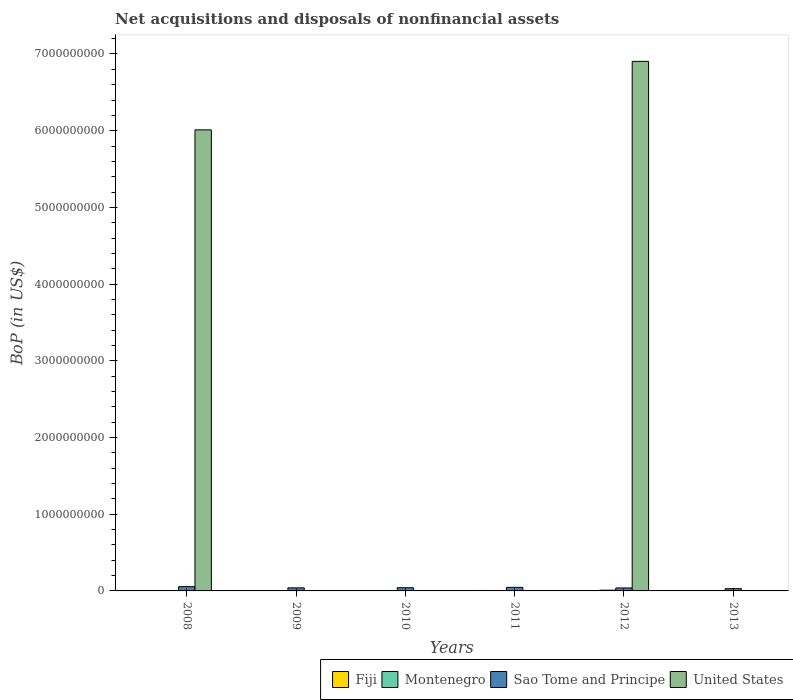How many bars are there on the 1st tick from the left?
Your answer should be compact. 3. In how many cases, is the number of bars for a given year not equal to the number of legend labels?
Give a very brief answer. 5. What is the Balance of Payments in Fiji in 2008?
Keep it short and to the point. 5.19e+06. Across all years, what is the maximum Balance of Payments in Montenegro?
Provide a short and direct response. 9.66e+06. Across all years, what is the minimum Balance of Payments in Sao Tome and Principe?
Give a very brief answer. 2.94e+07. In which year was the Balance of Payments in Fiji maximum?
Your response must be concise. 2011. What is the total Balance of Payments in United States in the graph?
Your response must be concise. 1.29e+1. What is the difference between the Balance of Payments in Fiji in 2009 and that in 2011?
Give a very brief answer. -3.56e+06. What is the difference between the Balance of Payments in Fiji in 2009 and the Balance of Payments in United States in 2013?
Provide a short and direct response. 2.36e+06. What is the average Balance of Payments in Sao Tome and Principe per year?
Provide a short and direct response. 4.20e+07. In the year 2009, what is the difference between the Balance of Payments in Montenegro and Balance of Payments in Fiji?
Offer a very short reply. 3.06e+05. In how many years, is the Balance of Payments in Fiji greater than 6600000000 US$?
Keep it short and to the point. 0. What is the ratio of the Balance of Payments in Fiji in 2009 to that in 2011?
Provide a succinct answer. 0.4. What is the difference between the highest and the second highest Balance of Payments in Fiji?
Provide a succinct answer. 7.21e+05. What is the difference between the highest and the lowest Balance of Payments in Sao Tome and Principe?
Offer a very short reply. 2.64e+07. In how many years, is the Balance of Payments in United States greater than the average Balance of Payments in United States taken over all years?
Your answer should be compact. 2. Is it the case that in every year, the sum of the Balance of Payments in Montenegro and Balance of Payments in Fiji is greater than the sum of Balance of Payments in United States and Balance of Payments in Sao Tome and Principe?
Give a very brief answer. No. Is it the case that in every year, the sum of the Balance of Payments in United States and Balance of Payments in Montenegro is greater than the Balance of Payments in Fiji?
Give a very brief answer. No. How many bars are there?
Your response must be concise. 17. Are all the bars in the graph horizontal?
Offer a terse response. No. How many years are there in the graph?
Your answer should be very brief. 6. Does the graph contain grids?
Provide a short and direct response. No. How many legend labels are there?
Ensure brevity in your answer.  4. What is the title of the graph?
Make the answer very short. Net acquisitions and disposals of nonfinancial assets. Does "Nicaragua" appear as one of the legend labels in the graph?
Offer a very short reply. No. What is the label or title of the Y-axis?
Your response must be concise. BoP (in US$). What is the BoP (in US$) in Fiji in 2008?
Keep it short and to the point. 5.19e+06. What is the BoP (in US$) in Montenegro in 2008?
Make the answer very short. 0. What is the BoP (in US$) in Sao Tome and Principe in 2008?
Offer a very short reply. 5.58e+07. What is the BoP (in US$) in United States in 2008?
Offer a terse response. 6.01e+09. What is the BoP (in US$) in Fiji in 2009?
Your answer should be compact. 2.36e+06. What is the BoP (in US$) in Montenegro in 2009?
Provide a succinct answer. 2.66e+06. What is the BoP (in US$) in Sao Tome and Principe in 2009?
Provide a succinct answer. 3.99e+07. What is the BoP (in US$) in United States in 2009?
Provide a succinct answer. 0. What is the BoP (in US$) in Fiji in 2010?
Provide a succinct answer. 2.92e+06. What is the BoP (in US$) of Sao Tome and Principe in 2010?
Offer a very short reply. 4.16e+07. What is the BoP (in US$) of Fiji in 2011?
Make the answer very short. 5.91e+06. What is the BoP (in US$) in Montenegro in 2011?
Ensure brevity in your answer.  0. What is the BoP (in US$) of Sao Tome and Principe in 2011?
Offer a very short reply. 4.65e+07. What is the BoP (in US$) of Fiji in 2012?
Provide a short and direct response. 3.96e+06. What is the BoP (in US$) in Montenegro in 2012?
Your answer should be very brief. 9.66e+06. What is the BoP (in US$) of Sao Tome and Principe in 2012?
Your response must be concise. 3.87e+07. What is the BoP (in US$) of United States in 2012?
Offer a terse response. 6.90e+09. What is the BoP (in US$) of Fiji in 2013?
Make the answer very short. 4.82e+06. What is the BoP (in US$) in Montenegro in 2013?
Provide a short and direct response. 3.47e+06. What is the BoP (in US$) of Sao Tome and Principe in 2013?
Provide a succinct answer. 2.94e+07. Across all years, what is the maximum BoP (in US$) in Fiji?
Give a very brief answer. 5.91e+06. Across all years, what is the maximum BoP (in US$) in Montenegro?
Keep it short and to the point. 9.66e+06. Across all years, what is the maximum BoP (in US$) of Sao Tome and Principe?
Keep it short and to the point. 5.58e+07. Across all years, what is the maximum BoP (in US$) in United States?
Give a very brief answer. 6.90e+09. Across all years, what is the minimum BoP (in US$) of Fiji?
Offer a terse response. 2.36e+06. Across all years, what is the minimum BoP (in US$) in Montenegro?
Offer a very short reply. 0. Across all years, what is the minimum BoP (in US$) of Sao Tome and Principe?
Ensure brevity in your answer.  2.94e+07. What is the total BoP (in US$) of Fiji in the graph?
Your answer should be very brief. 2.52e+07. What is the total BoP (in US$) of Montenegro in the graph?
Give a very brief answer. 1.58e+07. What is the total BoP (in US$) in Sao Tome and Principe in the graph?
Offer a terse response. 2.52e+08. What is the total BoP (in US$) in United States in the graph?
Keep it short and to the point. 1.29e+1. What is the difference between the BoP (in US$) of Fiji in 2008 and that in 2009?
Give a very brief answer. 2.84e+06. What is the difference between the BoP (in US$) of Sao Tome and Principe in 2008 and that in 2009?
Your response must be concise. 1.59e+07. What is the difference between the BoP (in US$) of Fiji in 2008 and that in 2010?
Offer a terse response. 2.27e+06. What is the difference between the BoP (in US$) of Sao Tome and Principe in 2008 and that in 2010?
Offer a very short reply. 1.41e+07. What is the difference between the BoP (in US$) in Fiji in 2008 and that in 2011?
Provide a short and direct response. -7.21e+05. What is the difference between the BoP (in US$) of Sao Tome and Principe in 2008 and that in 2011?
Give a very brief answer. 9.29e+06. What is the difference between the BoP (in US$) of Fiji in 2008 and that in 2012?
Offer a terse response. 1.23e+06. What is the difference between the BoP (in US$) of Sao Tome and Principe in 2008 and that in 2012?
Give a very brief answer. 1.71e+07. What is the difference between the BoP (in US$) of United States in 2008 and that in 2012?
Provide a succinct answer. -8.93e+08. What is the difference between the BoP (in US$) of Fiji in 2008 and that in 2013?
Ensure brevity in your answer.  3.70e+05. What is the difference between the BoP (in US$) in Sao Tome and Principe in 2008 and that in 2013?
Offer a terse response. 2.64e+07. What is the difference between the BoP (in US$) in Fiji in 2009 and that in 2010?
Offer a very short reply. -5.65e+05. What is the difference between the BoP (in US$) in Sao Tome and Principe in 2009 and that in 2010?
Make the answer very short. -1.75e+06. What is the difference between the BoP (in US$) in Fiji in 2009 and that in 2011?
Offer a very short reply. -3.56e+06. What is the difference between the BoP (in US$) in Sao Tome and Principe in 2009 and that in 2011?
Your answer should be compact. -6.60e+06. What is the difference between the BoP (in US$) in Fiji in 2009 and that in 2012?
Offer a terse response. -1.60e+06. What is the difference between the BoP (in US$) in Montenegro in 2009 and that in 2012?
Your answer should be compact. -6.99e+06. What is the difference between the BoP (in US$) of Sao Tome and Principe in 2009 and that in 2012?
Make the answer very short. 1.17e+06. What is the difference between the BoP (in US$) in Fiji in 2009 and that in 2013?
Provide a short and direct response. -2.47e+06. What is the difference between the BoP (in US$) in Montenegro in 2009 and that in 2013?
Make the answer very short. -8.10e+05. What is the difference between the BoP (in US$) of Sao Tome and Principe in 2009 and that in 2013?
Provide a succinct answer. 1.05e+07. What is the difference between the BoP (in US$) of Fiji in 2010 and that in 2011?
Your answer should be very brief. -2.99e+06. What is the difference between the BoP (in US$) of Sao Tome and Principe in 2010 and that in 2011?
Offer a terse response. -4.85e+06. What is the difference between the BoP (in US$) of Fiji in 2010 and that in 2012?
Offer a very short reply. -1.04e+06. What is the difference between the BoP (in US$) of Sao Tome and Principe in 2010 and that in 2012?
Ensure brevity in your answer.  2.92e+06. What is the difference between the BoP (in US$) in Fiji in 2010 and that in 2013?
Give a very brief answer. -1.90e+06. What is the difference between the BoP (in US$) in Sao Tome and Principe in 2010 and that in 2013?
Provide a short and direct response. 1.22e+07. What is the difference between the BoP (in US$) of Fiji in 2011 and that in 2012?
Your answer should be very brief. 1.95e+06. What is the difference between the BoP (in US$) of Sao Tome and Principe in 2011 and that in 2012?
Make the answer very short. 7.77e+06. What is the difference between the BoP (in US$) of Fiji in 2011 and that in 2013?
Ensure brevity in your answer.  1.09e+06. What is the difference between the BoP (in US$) in Sao Tome and Principe in 2011 and that in 2013?
Provide a succinct answer. 1.71e+07. What is the difference between the BoP (in US$) in Fiji in 2012 and that in 2013?
Offer a terse response. -8.61e+05. What is the difference between the BoP (in US$) in Montenegro in 2012 and that in 2013?
Your answer should be compact. 6.18e+06. What is the difference between the BoP (in US$) in Sao Tome and Principe in 2012 and that in 2013?
Give a very brief answer. 9.30e+06. What is the difference between the BoP (in US$) in Fiji in 2008 and the BoP (in US$) in Montenegro in 2009?
Offer a very short reply. 2.53e+06. What is the difference between the BoP (in US$) of Fiji in 2008 and the BoP (in US$) of Sao Tome and Principe in 2009?
Make the answer very short. -3.47e+07. What is the difference between the BoP (in US$) in Fiji in 2008 and the BoP (in US$) in Sao Tome and Principe in 2010?
Ensure brevity in your answer.  -3.64e+07. What is the difference between the BoP (in US$) of Fiji in 2008 and the BoP (in US$) of Sao Tome and Principe in 2011?
Make the answer very short. -4.13e+07. What is the difference between the BoP (in US$) in Fiji in 2008 and the BoP (in US$) in Montenegro in 2012?
Your answer should be compact. -4.46e+06. What is the difference between the BoP (in US$) of Fiji in 2008 and the BoP (in US$) of Sao Tome and Principe in 2012?
Your response must be concise. -3.35e+07. What is the difference between the BoP (in US$) of Fiji in 2008 and the BoP (in US$) of United States in 2012?
Keep it short and to the point. -6.90e+09. What is the difference between the BoP (in US$) in Sao Tome and Principe in 2008 and the BoP (in US$) in United States in 2012?
Your answer should be very brief. -6.85e+09. What is the difference between the BoP (in US$) in Fiji in 2008 and the BoP (in US$) in Montenegro in 2013?
Provide a short and direct response. 1.72e+06. What is the difference between the BoP (in US$) in Fiji in 2008 and the BoP (in US$) in Sao Tome and Principe in 2013?
Make the answer very short. -2.42e+07. What is the difference between the BoP (in US$) of Fiji in 2009 and the BoP (in US$) of Sao Tome and Principe in 2010?
Ensure brevity in your answer.  -3.93e+07. What is the difference between the BoP (in US$) in Montenegro in 2009 and the BoP (in US$) in Sao Tome and Principe in 2010?
Make the answer very short. -3.90e+07. What is the difference between the BoP (in US$) in Fiji in 2009 and the BoP (in US$) in Sao Tome and Principe in 2011?
Offer a very short reply. -4.41e+07. What is the difference between the BoP (in US$) of Montenegro in 2009 and the BoP (in US$) of Sao Tome and Principe in 2011?
Ensure brevity in your answer.  -4.38e+07. What is the difference between the BoP (in US$) of Fiji in 2009 and the BoP (in US$) of Montenegro in 2012?
Ensure brevity in your answer.  -7.30e+06. What is the difference between the BoP (in US$) in Fiji in 2009 and the BoP (in US$) in Sao Tome and Principe in 2012?
Provide a succinct answer. -3.64e+07. What is the difference between the BoP (in US$) of Fiji in 2009 and the BoP (in US$) of United States in 2012?
Give a very brief answer. -6.90e+09. What is the difference between the BoP (in US$) of Montenegro in 2009 and the BoP (in US$) of Sao Tome and Principe in 2012?
Make the answer very short. -3.61e+07. What is the difference between the BoP (in US$) in Montenegro in 2009 and the BoP (in US$) in United States in 2012?
Ensure brevity in your answer.  -6.90e+09. What is the difference between the BoP (in US$) in Sao Tome and Principe in 2009 and the BoP (in US$) in United States in 2012?
Offer a very short reply. -6.86e+09. What is the difference between the BoP (in US$) in Fiji in 2009 and the BoP (in US$) in Montenegro in 2013?
Provide a short and direct response. -1.12e+06. What is the difference between the BoP (in US$) of Fiji in 2009 and the BoP (in US$) of Sao Tome and Principe in 2013?
Ensure brevity in your answer.  -2.71e+07. What is the difference between the BoP (in US$) of Montenegro in 2009 and the BoP (in US$) of Sao Tome and Principe in 2013?
Your answer should be compact. -2.68e+07. What is the difference between the BoP (in US$) of Fiji in 2010 and the BoP (in US$) of Sao Tome and Principe in 2011?
Your answer should be compact. -4.36e+07. What is the difference between the BoP (in US$) of Fiji in 2010 and the BoP (in US$) of Montenegro in 2012?
Offer a terse response. -6.73e+06. What is the difference between the BoP (in US$) of Fiji in 2010 and the BoP (in US$) of Sao Tome and Principe in 2012?
Offer a very short reply. -3.58e+07. What is the difference between the BoP (in US$) in Fiji in 2010 and the BoP (in US$) in United States in 2012?
Provide a short and direct response. -6.90e+09. What is the difference between the BoP (in US$) in Sao Tome and Principe in 2010 and the BoP (in US$) in United States in 2012?
Your response must be concise. -6.86e+09. What is the difference between the BoP (in US$) of Fiji in 2010 and the BoP (in US$) of Montenegro in 2013?
Provide a succinct answer. -5.51e+05. What is the difference between the BoP (in US$) of Fiji in 2010 and the BoP (in US$) of Sao Tome and Principe in 2013?
Offer a very short reply. -2.65e+07. What is the difference between the BoP (in US$) in Fiji in 2011 and the BoP (in US$) in Montenegro in 2012?
Offer a very short reply. -3.74e+06. What is the difference between the BoP (in US$) in Fiji in 2011 and the BoP (in US$) in Sao Tome and Principe in 2012?
Give a very brief answer. -3.28e+07. What is the difference between the BoP (in US$) in Fiji in 2011 and the BoP (in US$) in United States in 2012?
Offer a terse response. -6.90e+09. What is the difference between the BoP (in US$) in Sao Tome and Principe in 2011 and the BoP (in US$) in United States in 2012?
Provide a short and direct response. -6.86e+09. What is the difference between the BoP (in US$) in Fiji in 2011 and the BoP (in US$) in Montenegro in 2013?
Offer a very short reply. 2.44e+06. What is the difference between the BoP (in US$) in Fiji in 2011 and the BoP (in US$) in Sao Tome and Principe in 2013?
Provide a short and direct response. -2.35e+07. What is the difference between the BoP (in US$) in Fiji in 2012 and the BoP (in US$) in Montenegro in 2013?
Keep it short and to the point. 4.88e+05. What is the difference between the BoP (in US$) of Fiji in 2012 and the BoP (in US$) of Sao Tome and Principe in 2013?
Provide a succinct answer. -2.55e+07. What is the difference between the BoP (in US$) of Montenegro in 2012 and the BoP (in US$) of Sao Tome and Principe in 2013?
Make the answer very short. -1.98e+07. What is the average BoP (in US$) of Fiji per year?
Provide a succinct answer. 4.19e+06. What is the average BoP (in US$) of Montenegro per year?
Provide a short and direct response. 2.63e+06. What is the average BoP (in US$) of Sao Tome and Principe per year?
Keep it short and to the point. 4.20e+07. What is the average BoP (in US$) in United States per year?
Your response must be concise. 2.15e+09. In the year 2008, what is the difference between the BoP (in US$) in Fiji and BoP (in US$) in Sao Tome and Principe?
Your answer should be very brief. -5.06e+07. In the year 2008, what is the difference between the BoP (in US$) in Fiji and BoP (in US$) in United States?
Provide a short and direct response. -6.01e+09. In the year 2008, what is the difference between the BoP (in US$) in Sao Tome and Principe and BoP (in US$) in United States?
Keep it short and to the point. -5.96e+09. In the year 2009, what is the difference between the BoP (in US$) of Fiji and BoP (in US$) of Montenegro?
Your answer should be compact. -3.06e+05. In the year 2009, what is the difference between the BoP (in US$) of Fiji and BoP (in US$) of Sao Tome and Principe?
Your answer should be very brief. -3.75e+07. In the year 2009, what is the difference between the BoP (in US$) in Montenegro and BoP (in US$) in Sao Tome and Principe?
Give a very brief answer. -3.72e+07. In the year 2010, what is the difference between the BoP (in US$) in Fiji and BoP (in US$) in Sao Tome and Principe?
Make the answer very short. -3.87e+07. In the year 2011, what is the difference between the BoP (in US$) in Fiji and BoP (in US$) in Sao Tome and Principe?
Your response must be concise. -4.06e+07. In the year 2012, what is the difference between the BoP (in US$) of Fiji and BoP (in US$) of Montenegro?
Your answer should be compact. -5.70e+06. In the year 2012, what is the difference between the BoP (in US$) in Fiji and BoP (in US$) in Sao Tome and Principe?
Your answer should be compact. -3.48e+07. In the year 2012, what is the difference between the BoP (in US$) of Fiji and BoP (in US$) of United States?
Your answer should be very brief. -6.90e+09. In the year 2012, what is the difference between the BoP (in US$) in Montenegro and BoP (in US$) in Sao Tome and Principe?
Make the answer very short. -2.91e+07. In the year 2012, what is the difference between the BoP (in US$) of Montenegro and BoP (in US$) of United States?
Provide a succinct answer. -6.89e+09. In the year 2012, what is the difference between the BoP (in US$) in Sao Tome and Principe and BoP (in US$) in United States?
Make the answer very short. -6.87e+09. In the year 2013, what is the difference between the BoP (in US$) of Fiji and BoP (in US$) of Montenegro?
Give a very brief answer. 1.35e+06. In the year 2013, what is the difference between the BoP (in US$) in Fiji and BoP (in US$) in Sao Tome and Principe?
Your response must be concise. -2.46e+07. In the year 2013, what is the difference between the BoP (in US$) of Montenegro and BoP (in US$) of Sao Tome and Principe?
Your response must be concise. -2.59e+07. What is the ratio of the BoP (in US$) in Fiji in 2008 to that in 2009?
Your response must be concise. 2.2. What is the ratio of the BoP (in US$) of Sao Tome and Principe in 2008 to that in 2009?
Make the answer very short. 1.4. What is the ratio of the BoP (in US$) of Fiji in 2008 to that in 2010?
Provide a succinct answer. 1.78. What is the ratio of the BoP (in US$) of Sao Tome and Principe in 2008 to that in 2010?
Make the answer very short. 1.34. What is the ratio of the BoP (in US$) of Fiji in 2008 to that in 2011?
Your response must be concise. 0.88. What is the ratio of the BoP (in US$) of Sao Tome and Principe in 2008 to that in 2011?
Give a very brief answer. 1.2. What is the ratio of the BoP (in US$) in Fiji in 2008 to that in 2012?
Your answer should be very brief. 1.31. What is the ratio of the BoP (in US$) in Sao Tome and Principe in 2008 to that in 2012?
Provide a short and direct response. 1.44. What is the ratio of the BoP (in US$) of United States in 2008 to that in 2012?
Offer a very short reply. 0.87. What is the ratio of the BoP (in US$) of Fiji in 2008 to that in 2013?
Ensure brevity in your answer.  1.08. What is the ratio of the BoP (in US$) of Sao Tome and Principe in 2008 to that in 2013?
Make the answer very short. 1.9. What is the ratio of the BoP (in US$) in Fiji in 2009 to that in 2010?
Your answer should be very brief. 0.81. What is the ratio of the BoP (in US$) in Sao Tome and Principe in 2009 to that in 2010?
Make the answer very short. 0.96. What is the ratio of the BoP (in US$) of Fiji in 2009 to that in 2011?
Make the answer very short. 0.4. What is the ratio of the BoP (in US$) in Sao Tome and Principe in 2009 to that in 2011?
Make the answer very short. 0.86. What is the ratio of the BoP (in US$) of Fiji in 2009 to that in 2012?
Your answer should be very brief. 0.59. What is the ratio of the BoP (in US$) of Montenegro in 2009 to that in 2012?
Provide a succinct answer. 0.28. What is the ratio of the BoP (in US$) in Sao Tome and Principe in 2009 to that in 2012?
Keep it short and to the point. 1.03. What is the ratio of the BoP (in US$) in Fiji in 2009 to that in 2013?
Your answer should be compact. 0.49. What is the ratio of the BoP (in US$) in Montenegro in 2009 to that in 2013?
Make the answer very short. 0.77. What is the ratio of the BoP (in US$) of Sao Tome and Principe in 2009 to that in 2013?
Provide a succinct answer. 1.36. What is the ratio of the BoP (in US$) of Fiji in 2010 to that in 2011?
Provide a short and direct response. 0.49. What is the ratio of the BoP (in US$) of Sao Tome and Principe in 2010 to that in 2011?
Your answer should be very brief. 0.9. What is the ratio of the BoP (in US$) of Fiji in 2010 to that in 2012?
Provide a succinct answer. 0.74. What is the ratio of the BoP (in US$) in Sao Tome and Principe in 2010 to that in 2012?
Provide a succinct answer. 1.08. What is the ratio of the BoP (in US$) in Fiji in 2010 to that in 2013?
Offer a very short reply. 0.61. What is the ratio of the BoP (in US$) of Sao Tome and Principe in 2010 to that in 2013?
Your answer should be compact. 1.42. What is the ratio of the BoP (in US$) of Fiji in 2011 to that in 2012?
Your answer should be very brief. 1.49. What is the ratio of the BoP (in US$) of Sao Tome and Principe in 2011 to that in 2012?
Offer a very short reply. 1.2. What is the ratio of the BoP (in US$) in Fiji in 2011 to that in 2013?
Keep it short and to the point. 1.23. What is the ratio of the BoP (in US$) in Sao Tome and Principe in 2011 to that in 2013?
Your response must be concise. 1.58. What is the ratio of the BoP (in US$) of Fiji in 2012 to that in 2013?
Your answer should be very brief. 0.82. What is the ratio of the BoP (in US$) in Montenegro in 2012 to that in 2013?
Your answer should be very brief. 2.78. What is the ratio of the BoP (in US$) in Sao Tome and Principe in 2012 to that in 2013?
Offer a very short reply. 1.32. What is the difference between the highest and the second highest BoP (in US$) of Fiji?
Make the answer very short. 7.21e+05. What is the difference between the highest and the second highest BoP (in US$) of Montenegro?
Keep it short and to the point. 6.18e+06. What is the difference between the highest and the second highest BoP (in US$) in Sao Tome and Principe?
Your response must be concise. 9.29e+06. What is the difference between the highest and the lowest BoP (in US$) of Fiji?
Provide a short and direct response. 3.56e+06. What is the difference between the highest and the lowest BoP (in US$) of Montenegro?
Your response must be concise. 9.66e+06. What is the difference between the highest and the lowest BoP (in US$) in Sao Tome and Principe?
Make the answer very short. 2.64e+07. What is the difference between the highest and the lowest BoP (in US$) of United States?
Offer a very short reply. 6.90e+09. 